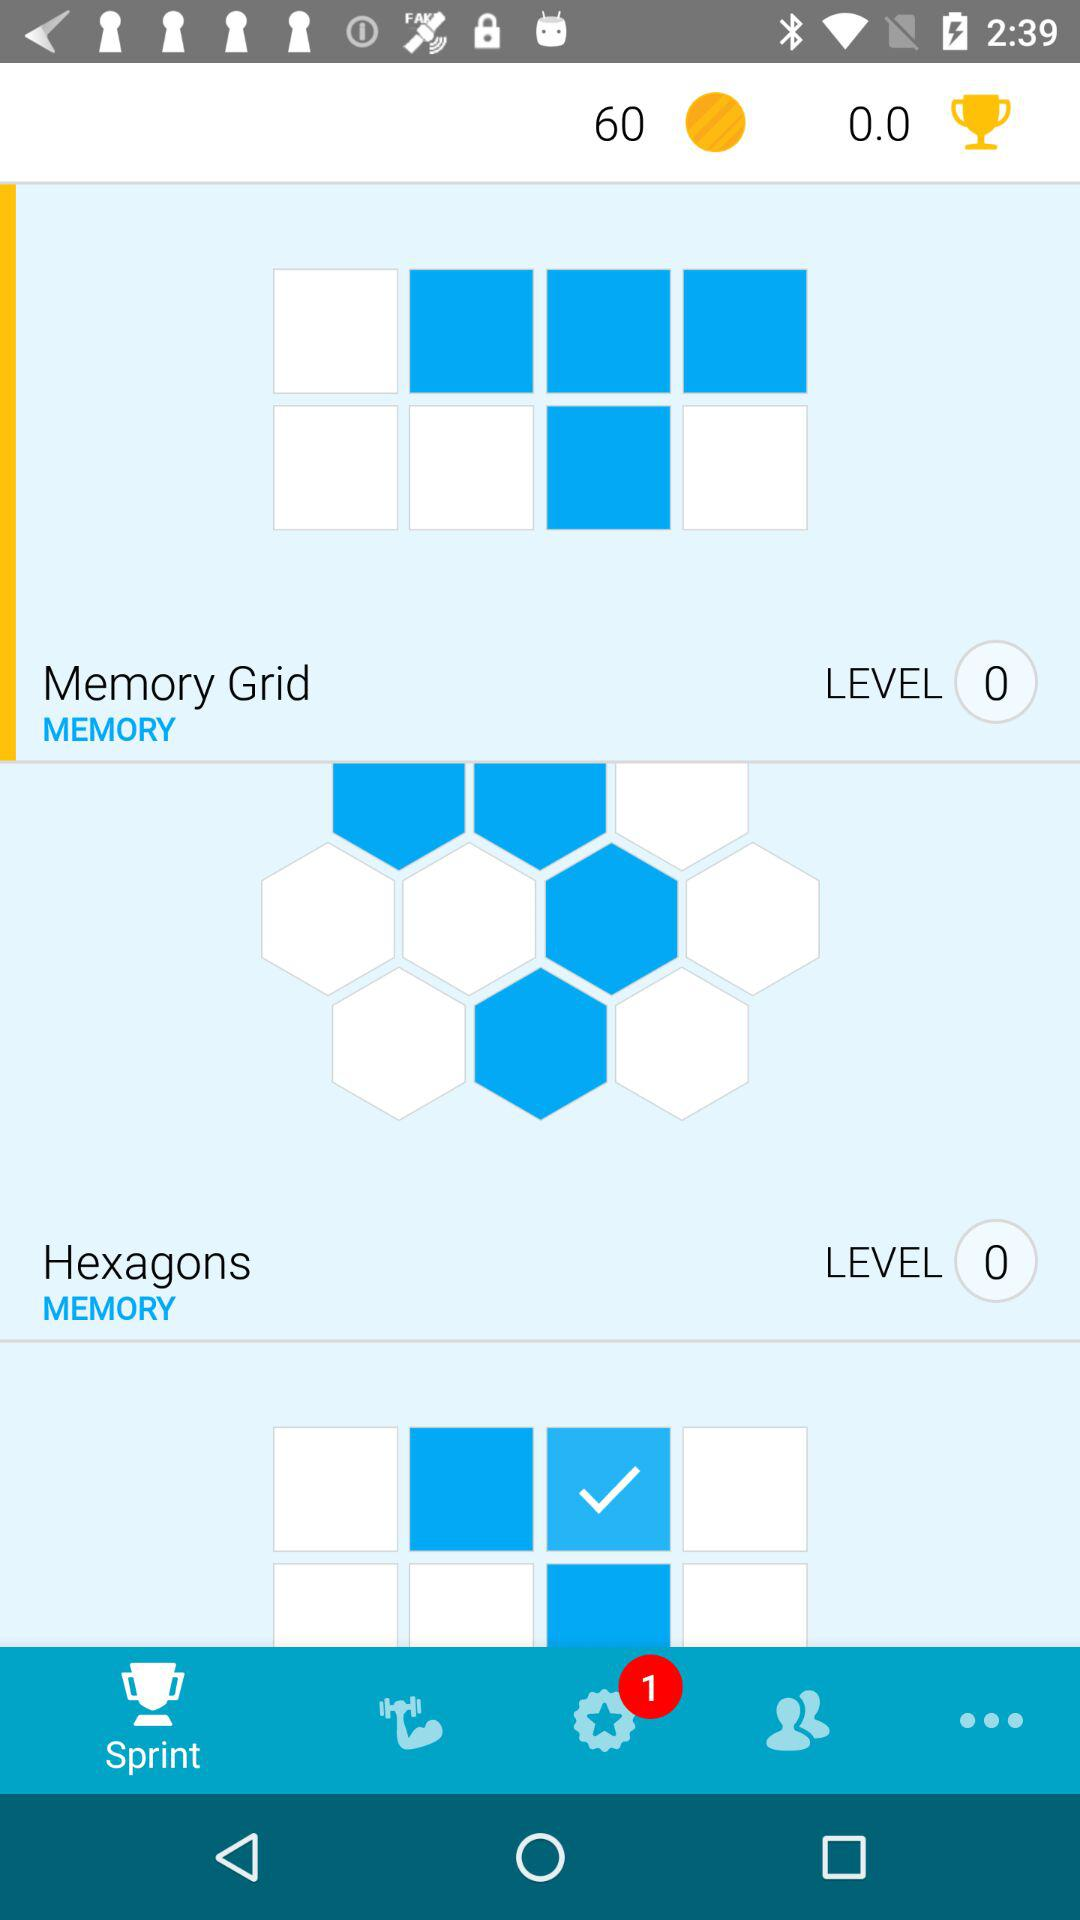How many coins are there? There are 60 coins. 